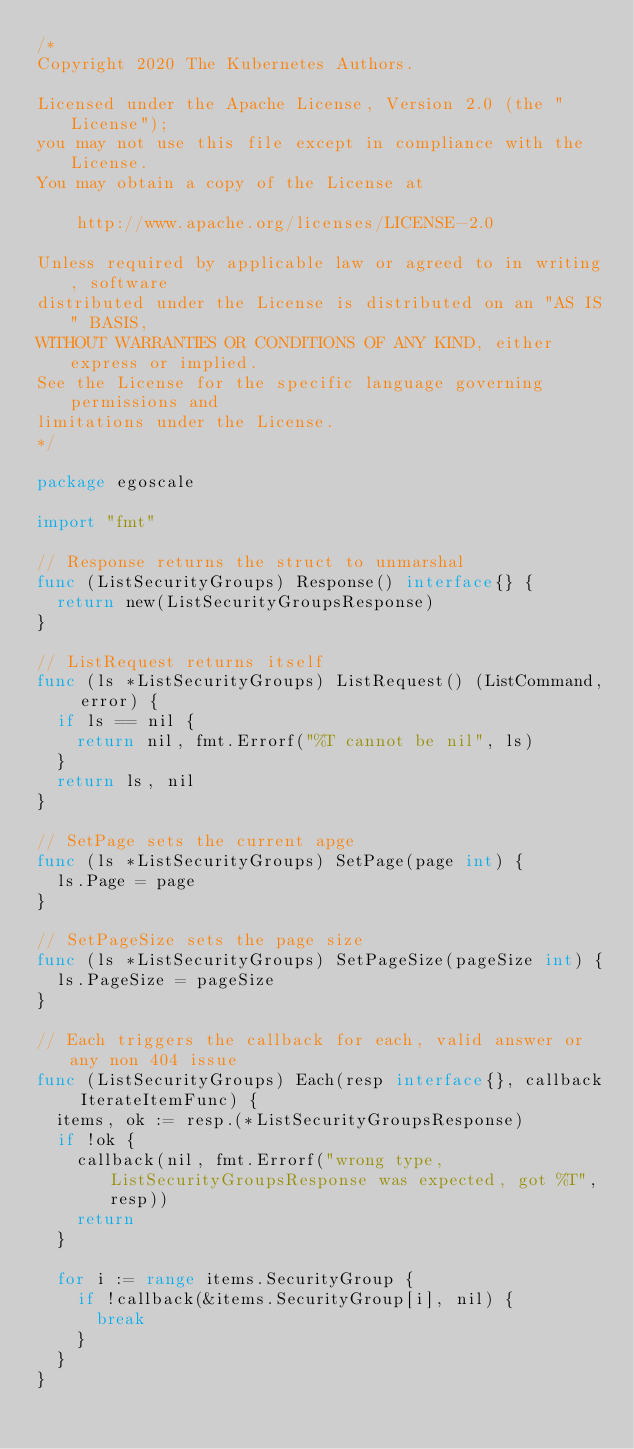Convert code to text. <code><loc_0><loc_0><loc_500><loc_500><_Go_>/*
Copyright 2020 The Kubernetes Authors.

Licensed under the Apache License, Version 2.0 (the "License");
you may not use this file except in compliance with the License.
You may obtain a copy of the License at

    http://www.apache.org/licenses/LICENSE-2.0

Unless required by applicable law or agreed to in writing, software
distributed under the License is distributed on an "AS IS" BASIS,
WITHOUT WARRANTIES OR CONDITIONS OF ANY KIND, either express or implied.
See the License for the specific language governing permissions and
limitations under the License.
*/

package egoscale

import "fmt"

// Response returns the struct to unmarshal
func (ListSecurityGroups) Response() interface{} {
	return new(ListSecurityGroupsResponse)
}

// ListRequest returns itself
func (ls *ListSecurityGroups) ListRequest() (ListCommand, error) {
	if ls == nil {
		return nil, fmt.Errorf("%T cannot be nil", ls)
	}
	return ls, nil
}

// SetPage sets the current apge
func (ls *ListSecurityGroups) SetPage(page int) {
	ls.Page = page
}

// SetPageSize sets the page size
func (ls *ListSecurityGroups) SetPageSize(pageSize int) {
	ls.PageSize = pageSize
}

// Each triggers the callback for each, valid answer or any non 404 issue
func (ListSecurityGroups) Each(resp interface{}, callback IterateItemFunc) {
	items, ok := resp.(*ListSecurityGroupsResponse)
	if !ok {
		callback(nil, fmt.Errorf("wrong type, ListSecurityGroupsResponse was expected, got %T", resp))
		return
	}

	for i := range items.SecurityGroup {
		if !callback(&items.SecurityGroup[i], nil) {
			break
		}
	}
}
</code> 